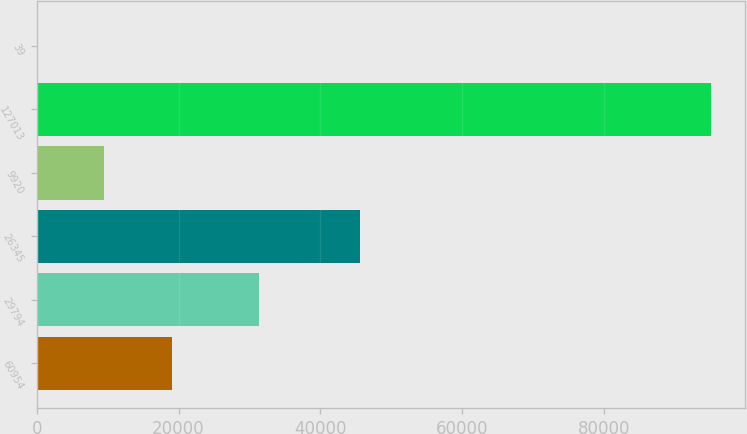Convert chart to OTSL. <chart><loc_0><loc_0><loc_500><loc_500><bar_chart><fcel>60954<fcel>29794<fcel>26345<fcel>9920<fcel>127013<fcel>39<nl><fcel>19044.4<fcel>31284<fcel>45609<fcel>9536.7<fcel>95106<fcel>29<nl></chart> 